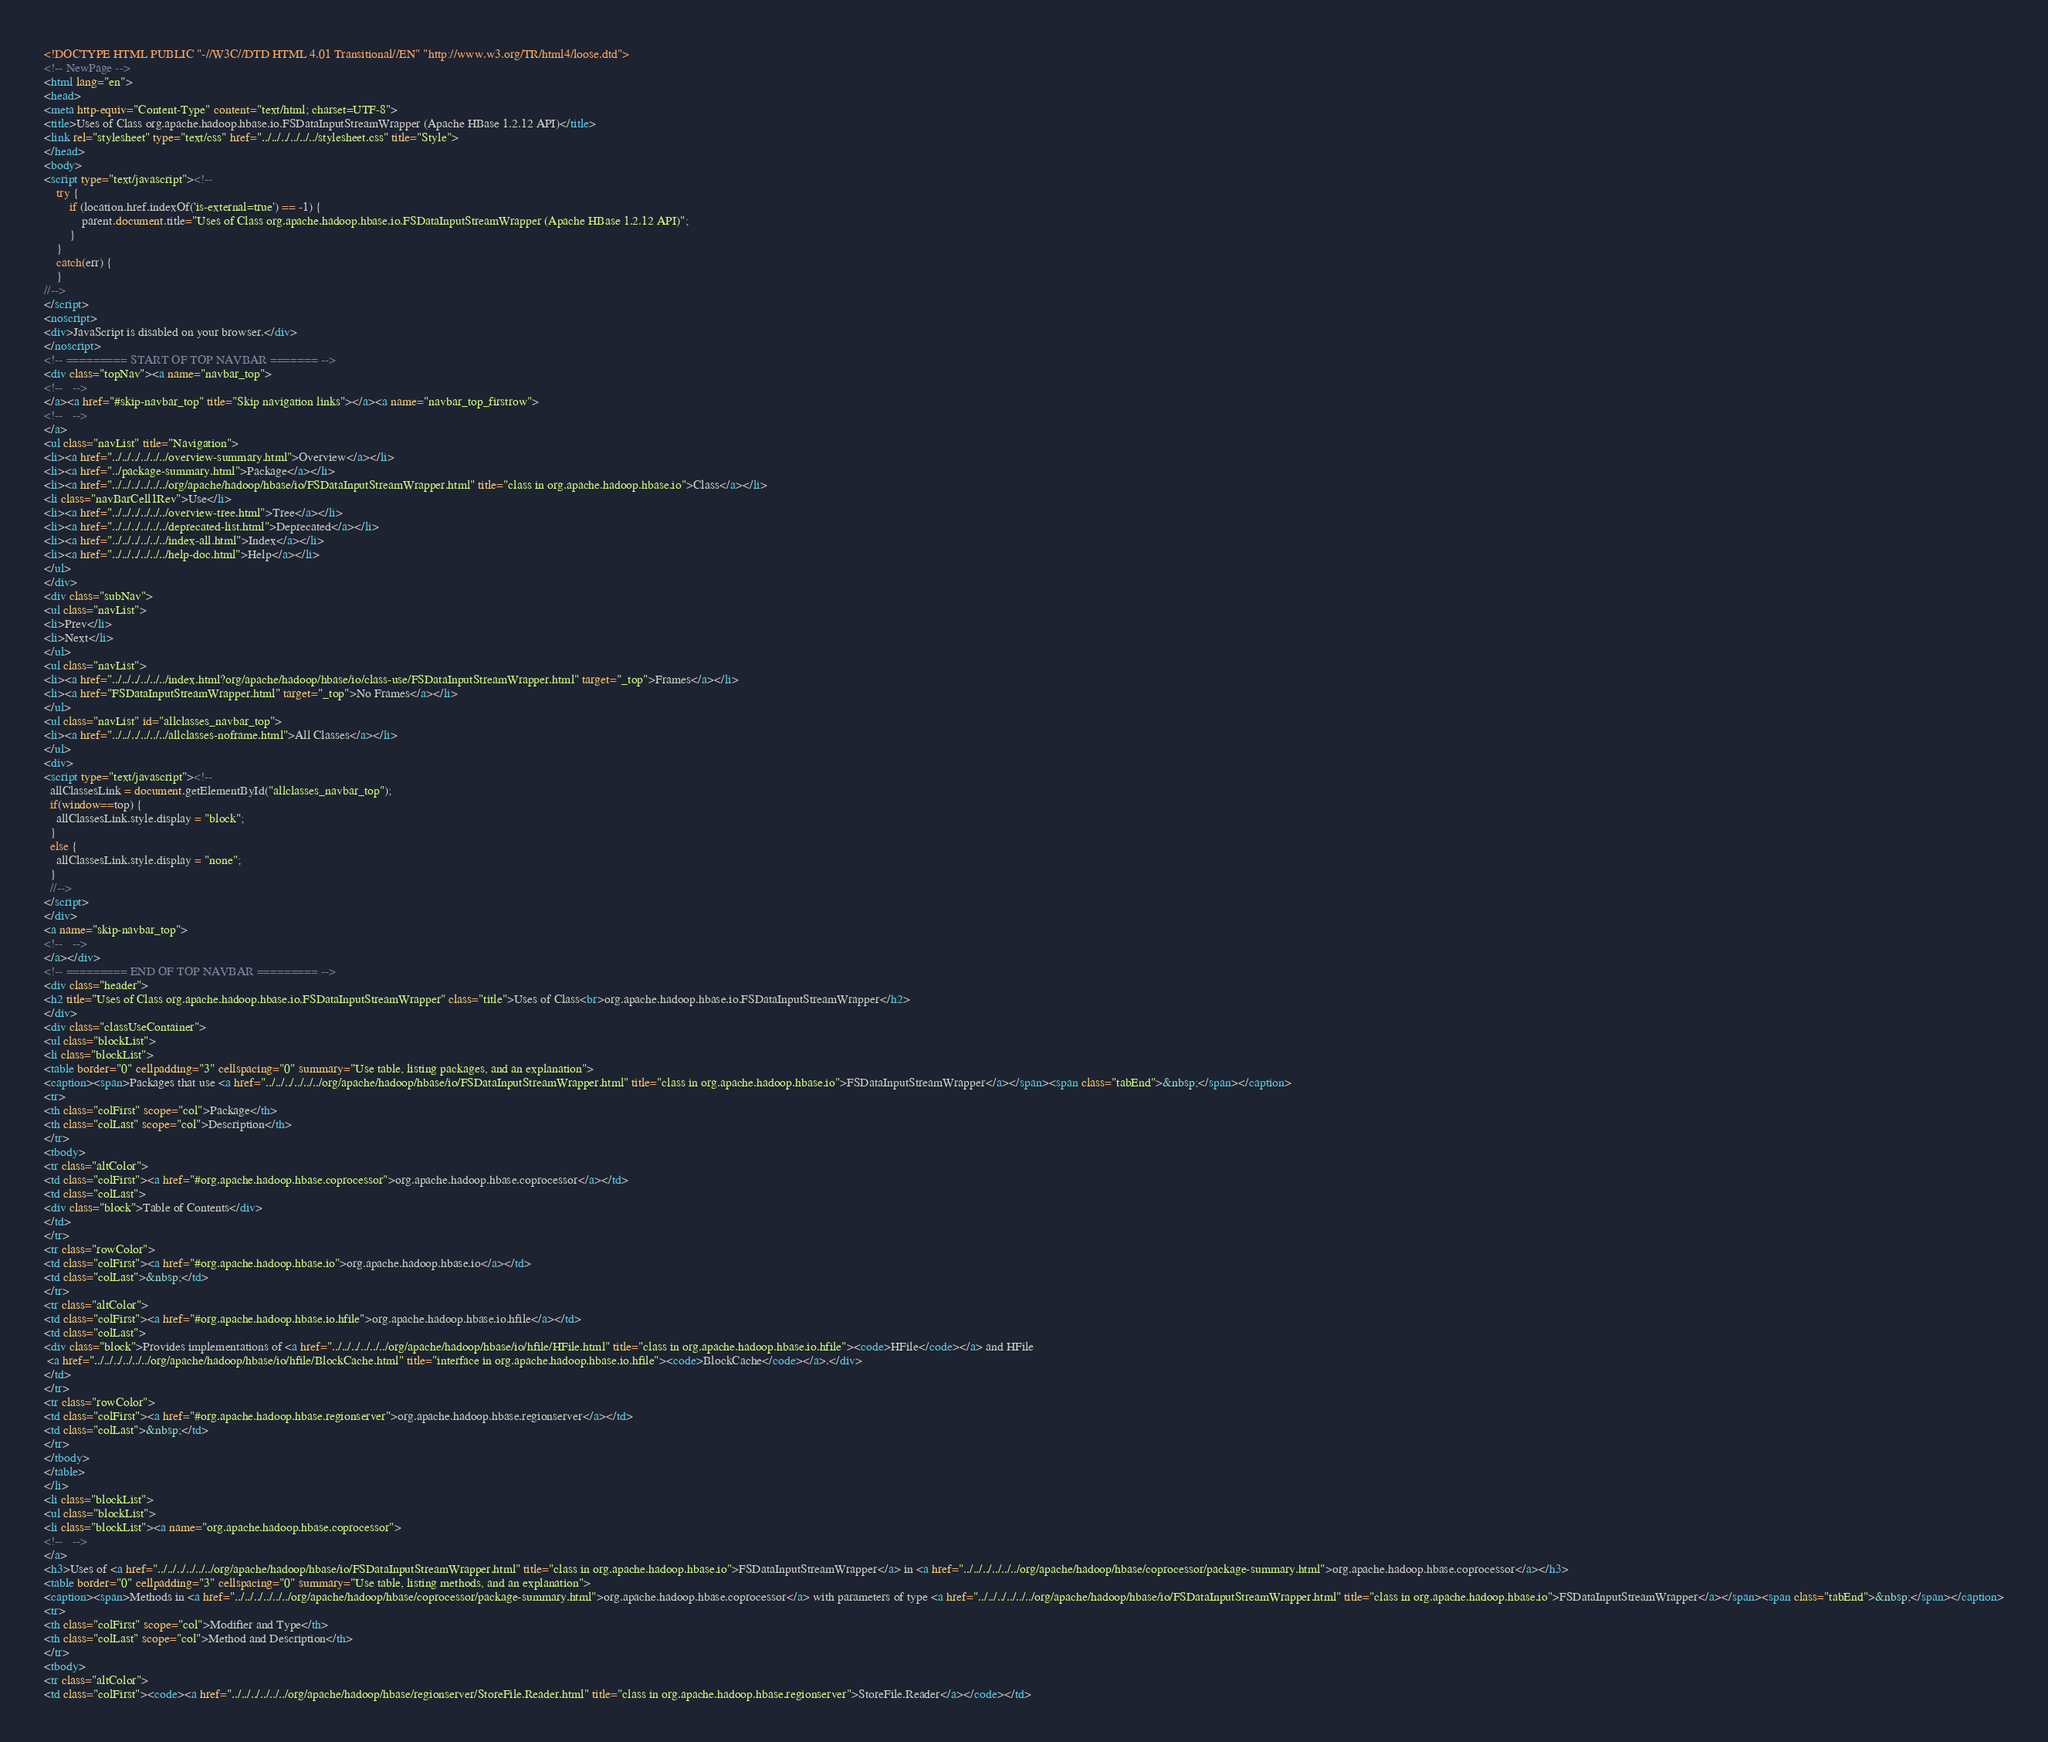Convert code to text. <code><loc_0><loc_0><loc_500><loc_500><_HTML_><!DOCTYPE HTML PUBLIC "-//W3C//DTD HTML 4.01 Transitional//EN" "http://www.w3.org/TR/html4/loose.dtd">
<!-- NewPage -->
<html lang="en">
<head>
<meta http-equiv="Content-Type" content="text/html; charset=UTF-8">
<title>Uses of Class org.apache.hadoop.hbase.io.FSDataInputStreamWrapper (Apache HBase 1.2.12 API)</title>
<link rel="stylesheet" type="text/css" href="../../../../../../stylesheet.css" title="Style">
</head>
<body>
<script type="text/javascript"><!--
    try {
        if (location.href.indexOf('is-external=true') == -1) {
            parent.document.title="Uses of Class org.apache.hadoop.hbase.io.FSDataInputStreamWrapper (Apache HBase 1.2.12 API)";
        }
    }
    catch(err) {
    }
//-->
</script>
<noscript>
<div>JavaScript is disabled on your browser.</div>
</noscript>
<!-- ========= START OF TOP NAVBAR ======= -->
<div class="topNav"><a name="navbar_top">
<!--   -->
</a><a href="#skip-navbar_top" title="Skip navigation links"></a><a name="navbar_top_firstrow">
<!--   -->
</a>
<ul class="navList" title="Navigation">
<li><a href="../../../../../../overview-summary.html">Overview</a></li>
<li><a href="../package-summary.html">Package</a></li>
<li><a href="../../../../../../org/apache/hadoop/hbase/io/FSDataInputStreamWrapper.html" title="class in org.apache.hadoop.hbase.io">Class</a></li>
<li class="navBarCell1Rev">Use</li>
<li><a href="../../../../../../overview-tree.html">Tree</a></li>
<li><a href="../../../../../../deprecated-list.html">Deprecated</a></li>
<li><a href="../../../../../../index-all.html">Index</a></li>
<li><a href="../../../../../../help-doc.html">Help</a></li>
</ul>
</div>
<div class="subNav">
<ul class="navList">
<li>Prev</li>
<li>Next</li>
</ul>
<ul class="navList">
<li><a href="../../../../../../index.html?org/apache/hadoop/hbase/io/class-use/FSDataInputStreamWrapper.html" target="_top">Frames</a></li>
<li><a href="FSDataInputStreamWrapper.html" target="_top">No Frames</a></li>
</ul>
<ul class="navList" id="allclasses_navbar_top">
<li><a href="../../../../../../allclasses-noframe.html">All Classes</a></li>
</ul>
<div>
<script type="text/javascript"><!--
  allClassesLink = document.getElementById("allclasses_navbar_top");
  if(window==top) {
    allClassesLink.style.display = "block";
  }
  else {
    allClassesLink.style.display = "none";
  }
  //-->
</script>
</div>
<a name="skip-navbar_top">
<!--   -->
</a></div>
<!-- ========= END OF TOP NAVBAR ========= -->
<div class="header">
<h2 title="Uses of Class org.apache.hadoop.hbase.io.FSDataInputStreamWrapper" class="title">Uses of Class<br>org.apache.hadoop.hbase.io.FSDataInputStreamWrapper</h2>
</div>
<div class="classUseContainer">
<ul class="blockList">
<li class="blockList">
<table border="0" cellpadding="3" cellspacing="0" summary="Use table, listing packages, and an explanation">
<caption><span>Packages that use <a href="../../../../../../org/apache/hadoop/hbase/io/FSDataInputStreamWrapper.html" title="class in org.apache.hadoop.hbase.io">FSDataInputStreamWrapper</a></span><span class="tabEnd">&nbsp;</span></caption>
<tr>
<th class="colFirst" scope="col">Package</th>
<th class="colLast" scope="col">Description</th>
</tr>
<tbody>
<tr class="altColor">
<td class="colFirst"><a href="#org.apache.hadoop.hbase.coprocessor">org.apache.hadoop.hbase.coprocessor</a></td>
<td class="colLast">
<div class="block">Table of Contents</div>
</td>
</tr>
<tr class="rowColor">
<td class="colFirst"><a href="#org.apache.hadoop.hbase.io">org.apache.hadoop.hbase.io</a></td>
<td class="colLast">&nbsp;</td>
</tr>
<tr class="altColor">
<td class="colFirst"><a href="#org.apache.hadoop.hbase.io.hfile">org.apache.hadoop.hbase.io.hfile</a></td>
<td class="colLast">
<div class="block">Provides implementations of <a href="../../../../../../org/apache/hadoop/hbase/io/hfile/HFile.html" title="class in org.apache.hadoop.hbase.io.hfile"><code>HFile</code></a> and HFile
 <a href="../../../../../../org/apache/hadoop/hbase/io/hfile/BlockCache.html" title="interface in org.apache.hadoop.hbase.io.hfile"><code>BlockCache</code></a>.</div>
</td>
</tr>
<tr class="rowColor">
<td class="colFirst"><a href="#org.apache.hadoop.hbase.regionserver">org.apache.hadoop.hbase.regionserver</a></td>
<td class="colLast">&nbsp;</td>
</tr>
</tbody>
</table>
</li>
<li class="blockList">
<ul class="blockList">
<li class="blockList"><a name="org.apache.hadoop.hbase.coprocessor">
<!--   -->
</a>
<h3>Uses of <a href="../../../../../../org/apache/hadoop/hbase/io/FSDataInputStreamWrapper.html" title="class in org.apache.hadoop.hbase.io">FSDataInputStreamWrapper</a> in <a href="../../../../../../org/apache/hadoop/hbase/coprocessor/package-summary.html">org.apache.hadoop.hbase.coprocessor</a></h3>
<table border="0" cellpadding="3" cellspacing="0" summary="Use table, listing methods, and an explanation">
<caption><span>Methods in <a href="../../../../../../org/apache/hadoop/hbase/coprocessor/package-summary.html">org.apache.hadoop.hbase.coprocessor</a> with parameters of type <a href="../../../../../../org/apache/hadoop/hbase/io/FSDataInputStreamWrapper.html" title="class in org.apache.hadoop.hbase.io">FSDataInputStreamWrapper</a></span><span class="tabEnd">&nbsp;</span></caption>
<tr>
<th class="colFirst" scope="col">Modifier and Type</th>
<th class="colLast" scope="col">Method and Description</th>
</tr>
<tbody>
<tr class="altColor">
<td class="colFirst"><code><a href="../../../../../../org/apache/hadoop/hbase/regionserver/StoreFile.Reader.html" title="class in org.apache.hadoop.hbase.regionserver">StoreFile.Reader</a></code></td></code> 